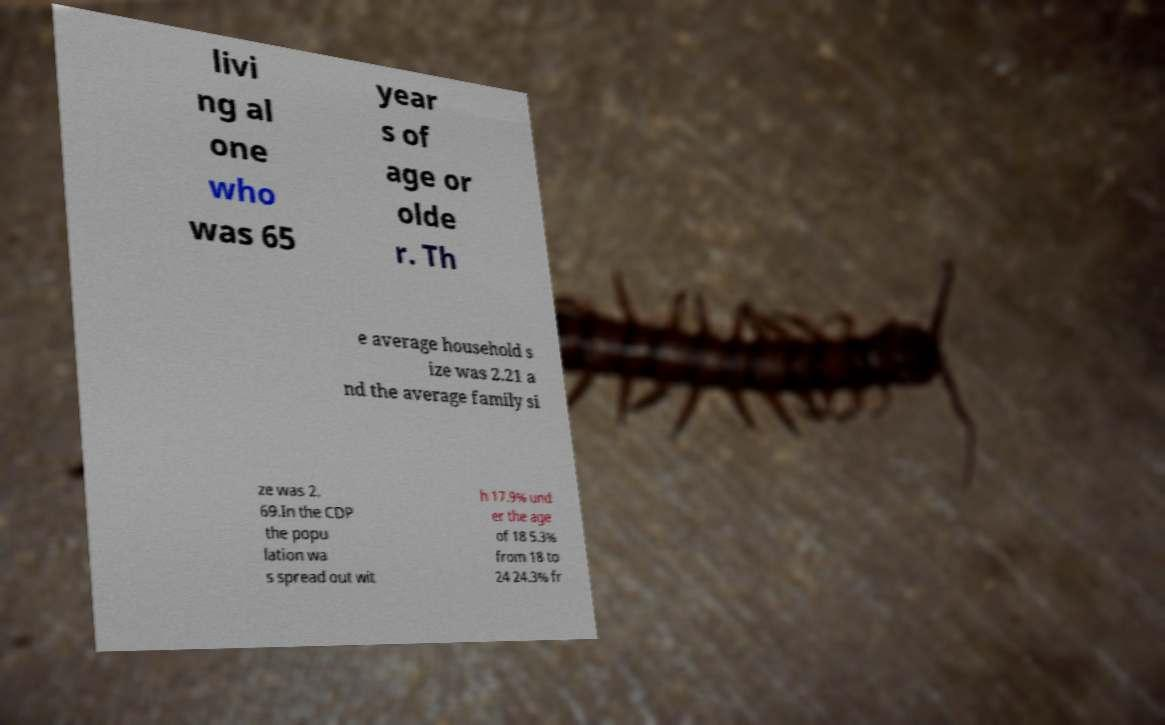There's text embedded in this image that I need extracted. Can you transcribe it verbatim? livi ng al one who was 65 year s of age or olde r. Th e average household s ize was 2.21 a nd the average family si ze was 2. 69.In the CDP the popu lation wa s spread out wit h 17.9% und er the age of 18 5.3% from 18 to 24 24.3% fr 